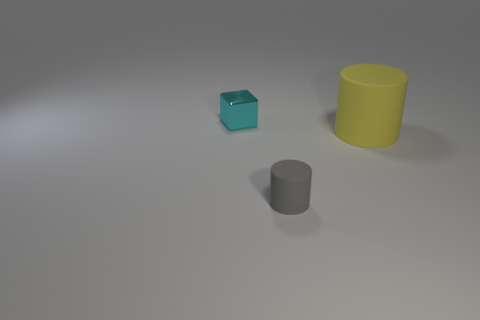Are there any gray things made of the same material as the big cylinder?
Make the answer very short. Yes. How many tiny blue matte things are there?
Ensure brevity in your answer.  0. Does the tiny gray thing have the same material as the small thing behind the big cylinder?
Make the answer very short. No. How many tiny cubes are the same color as the big cylinder?
Your answer should be very brief. 0. What is the size of the gray cylinder?
Provide a succinct answer. Small. Do the cyan metallic object and the object to the right of the gray rubber object have the same shape?
Offer a very short reply. No. There is a cylinder that is the same material as the gray thing; what is its color?
Give a very brief answer. Yellow. There is a cylinder that is on the left side of the large yellow matte cylinder; what size is it?
Provide a succinct answer. Small. Are there fewer large yellow matte cylinders right of the tiny cyan metal cube than small cyan objects?
Your response must be concise. No. Is there any other thing that has the same shape as the tiny cyan object?
Provide a succinct answer. No. 